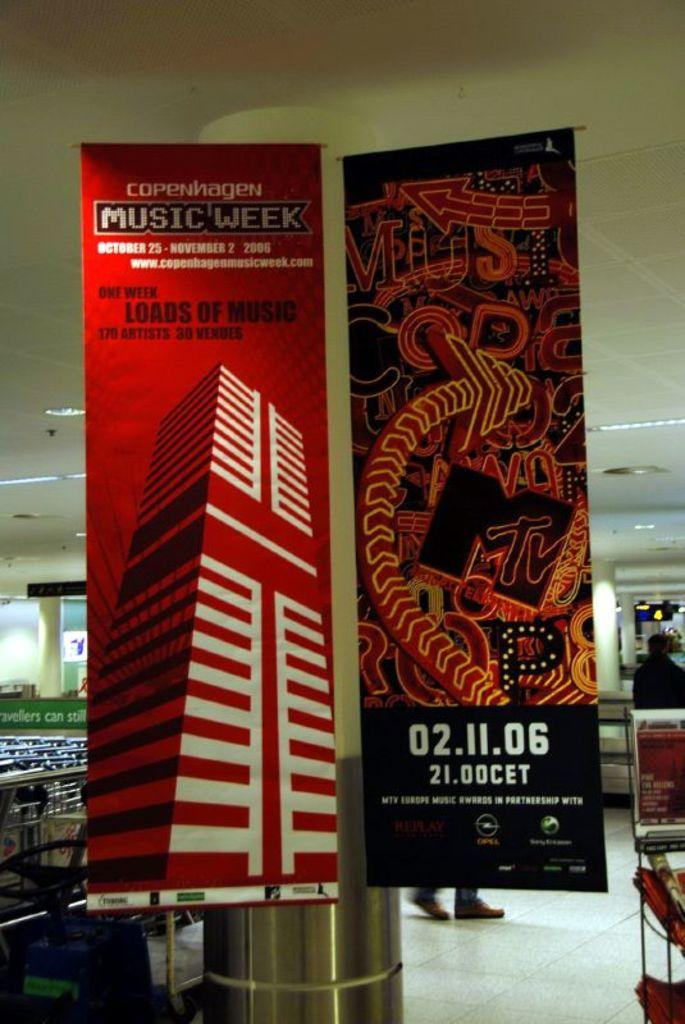What is located near the pillar in the image? There are banners near a pillar in the image. What type of furniture can be seen on the left side of the image? There are chairs and tables on the left side of the image. Where is the person standing in the image? The person is standing near a table on the right side of the image. What can be seen providing illumination in the image? Lights are visible in the image. What type of patch is sewn onto the scarecrow's clothing in the image? There is no scarecrow present in the image, so there is no patch to describe. How does the person slip on the floor in the image? There is no indication of anyone slipping in the image; the person is standing near a table. 